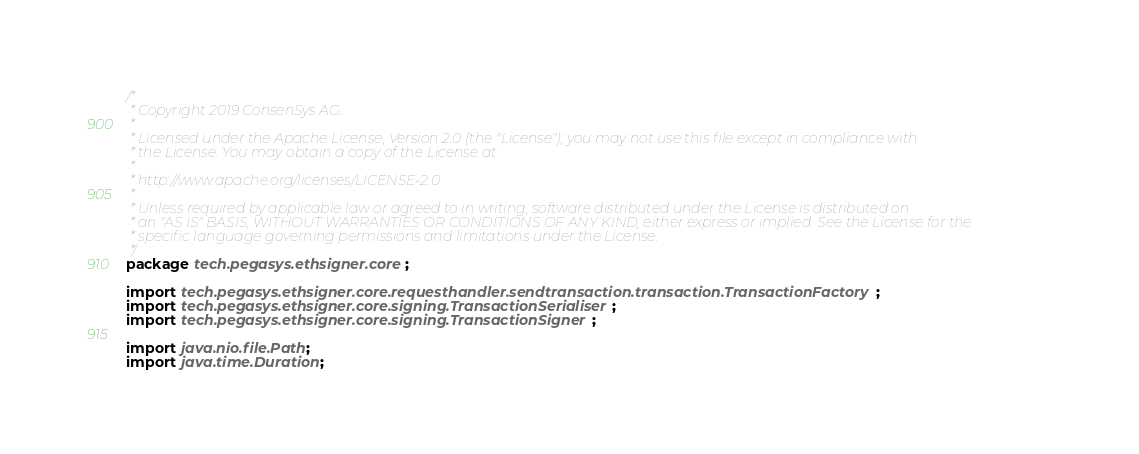Convert code to text. <code><loc_0><loc_0><loc_500><loc_500><_Java_>/*
 * Copyright 2019 ConsenSys AG.
 *
 * Licensed under the Apache License, Version 2.0 (the "License"); you may not use this file except in compliance with
 * the License. You may obtain a copy of the License at
 *
 * http://www.apache.org/licenses/LICENSE-2.0
 *
 * Unless required by applicable law or agreed to in writing, software distributed under the License is distributed on
 * an "AS IS" BASIS, WITHOUT WARRANTIES OR CONDITIONS OF ANY KIND, either express or implied. See the License for the
 * specific language governing permissions and limitations under the License.
 */
package tech.pegasys.ethsigner.core;

import tech.pegasys.ethsigner.core.requesthandler.sendtransaction.transaction.TransactionFactory;
import tech.pegasys.ethsigner.core.signing.TransactionSerialiser;
import tech.pegasys.ethsigner.core.signing.TransactionSigner;

import java.nio.file.Path;
import java.time.Duration;
</code> 